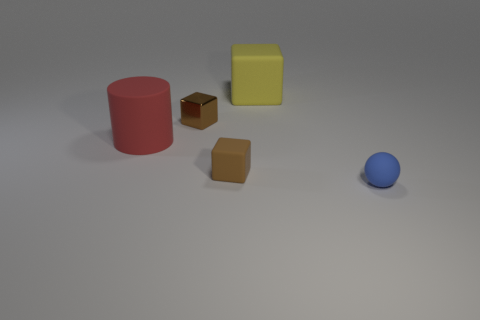Are there any other things that have the same material as the blue ball?
Provide a succinct answer. Yes. What is the color of the tiny rubber block?
Your response must be concise. Brown. What is the color of the rubber block that is the same size as the red cylinder?
Make the answer very short. Yellow. How many metallic objects are red things or large green cylinders?
Your answer should be very brief. 0. What number of things are behind the big red cylinder and to the left of the brown rubber block?
Offer a terse response. 1. Is there anything else that is the same shape as the blue rubber thing?
Your response must be concise. No. How many other objects are the same size as the blue rubber thing?
Ensure brevity in your answer.  2. Is the size of the rubber cube behind the red matte object the same as the red thing that is on the left side of the metal cube?
Give a very brief answer. Yes. What number of objects are yellow rubber things or matte cubes that are behind the brown metal cube?
Make the answer very short. 1. How big is the matte cube that is behind the brown shiny object?
Provide a short and direct response. Large. 